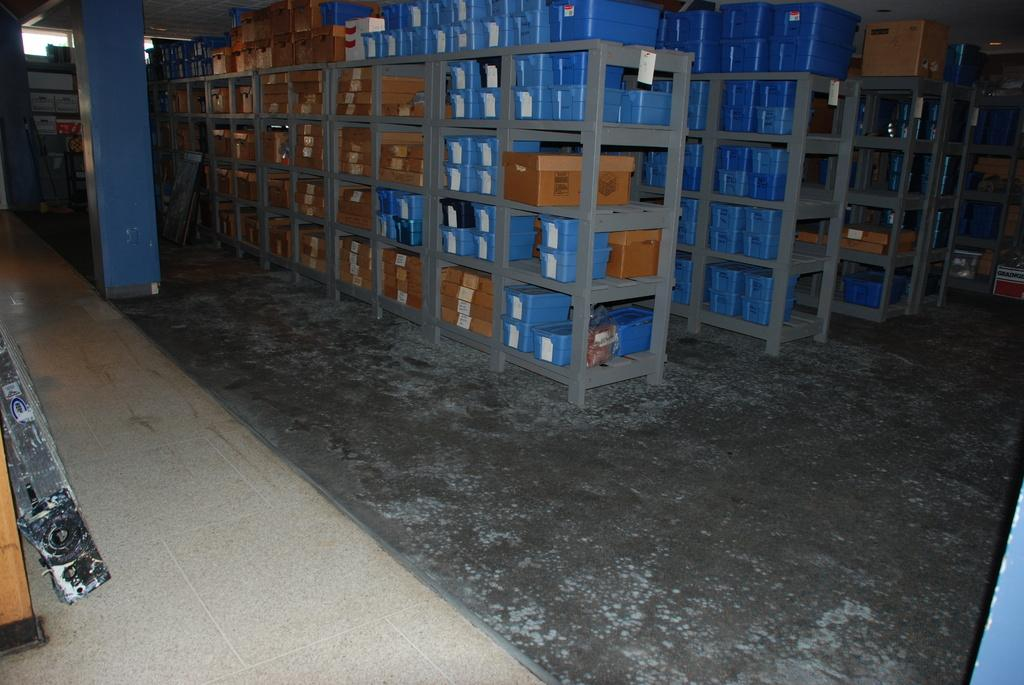What can be seen in the image that is used for storage? There are racks in the image that are used for storage. What are the racks holding? The racks contain boxes. Where is a prominent architectural feature located in the image? There is a pillar in the top left of the image. Is there a picture of a stretch of property in the image? There is no picture of a stretch of property in the image; it features racks with boxes and a pillar. 